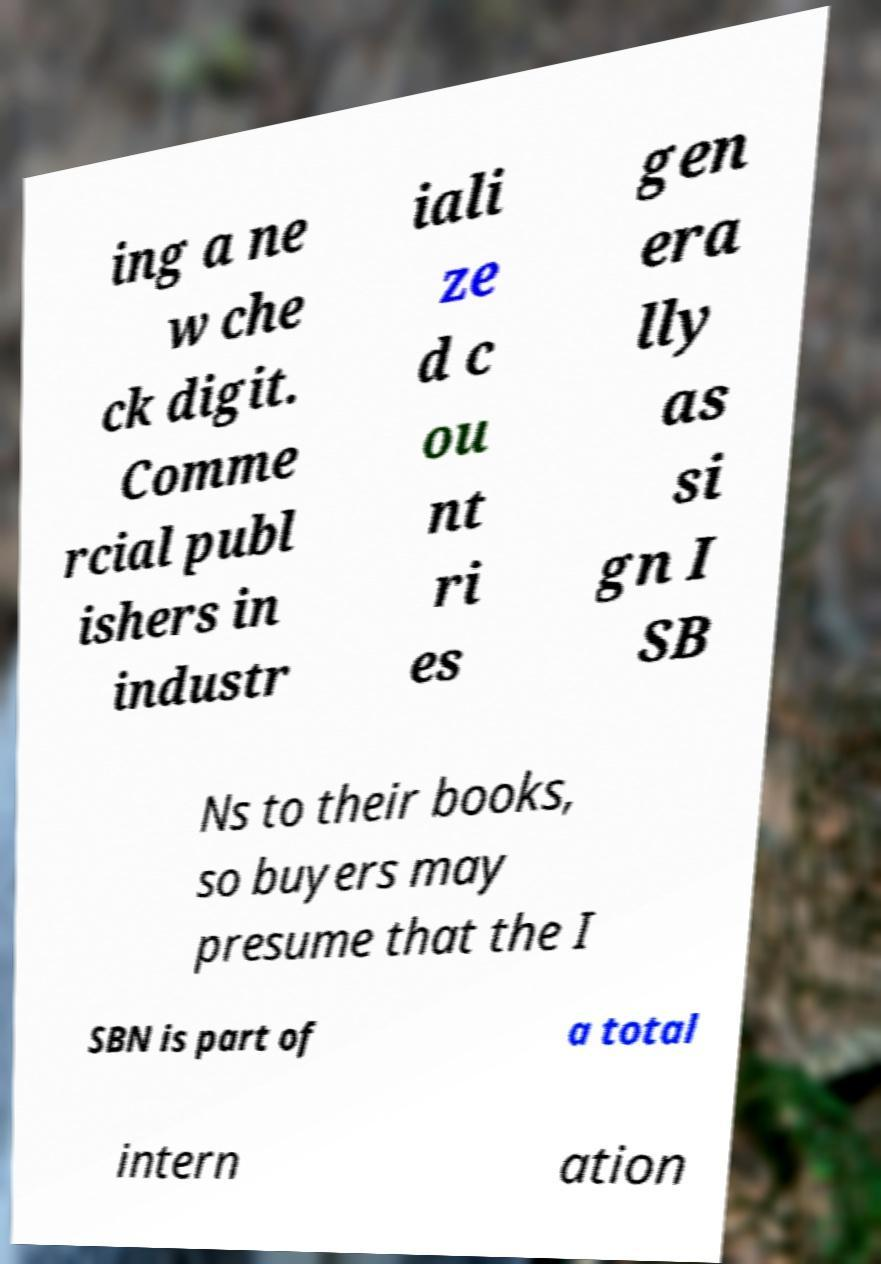Can you read and provide the text displayed in the image?This photo seems to have some interesting text. Can you extract and type it out for me? ing a ne w che ck digit. Comme rcial publ ishers in industr iali ze d c ou nt ri es gen era lly as si gn I SB Ns to their books, so buyers may presume that the I SBN is part of a total intern ation 